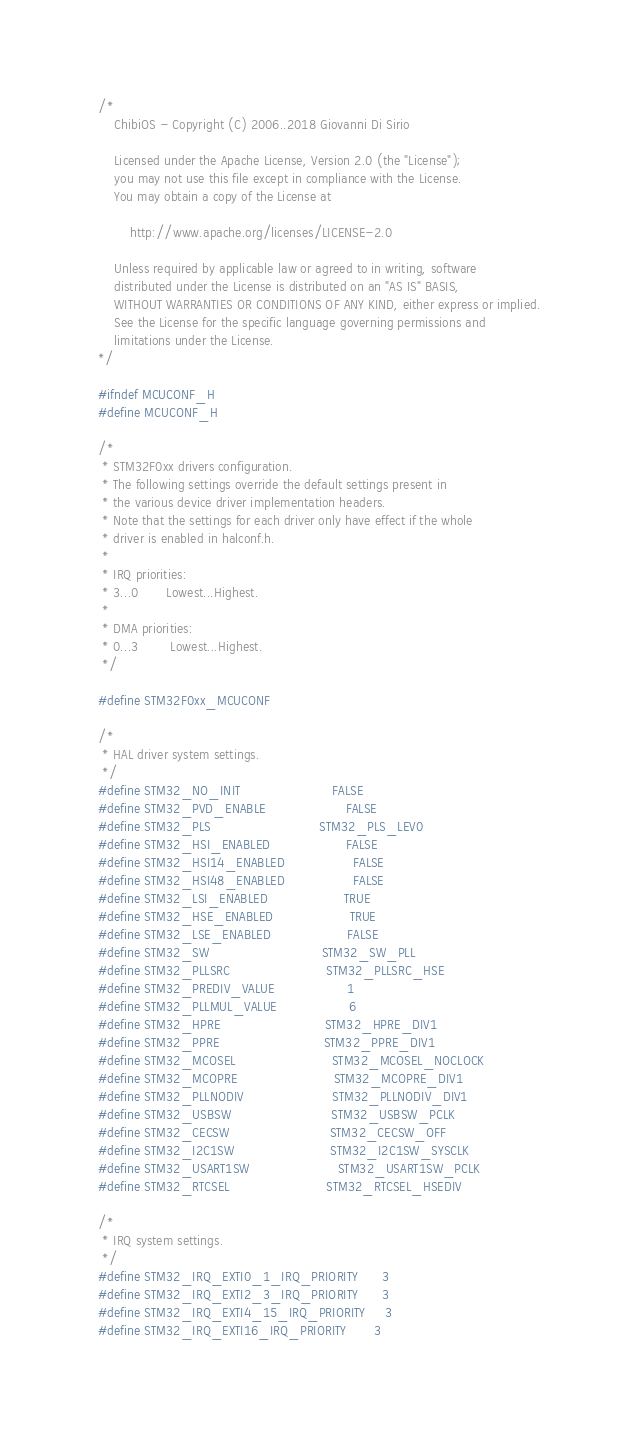Convert code to text. <code><loc_0><loc_0><loc_500><loc_500><_C_>/*
    ChibiOS - Copyright (C) 2006..2018 Giovanni Di Sirio

    Licensed under the Apache License, Version 2.0 (the "License");
    you may not use this file except in compliance with the License.
    You may obtain a copy of the License at

        http://www.apache.org/licenses/LICENSE-2.0

    Unless required by applicable law or agreed to in writing, software
    distributed under the License is distributed on an "AS IS" BASIS,
    WITHOUT WARRANTIES OR CONDITIONS OF ANY KIND, either express or implied.
    See the License for the specific language governing permissions and
    limitations under the License.
*/

#ifndef MCUCONF_H
#define MCUCONF_H

/*
 * STM32F0xx drivers configuration.
 * The following settings override the default settings present in
 * the various device driver implementation headers.
 * Note that the settings for each driver only have effect if the whole
 * driver is enabled in halconf.h.
 *
 * IRQ priorities:
 * 3...0       Lowest...Highest.
 *
 * DMA priorities:
 * 0...3        Lowest...Highest.
 */

#define STM32F0xx_MCUCONF

/*
 * HAL driver system settings.
 */
#define STM32_NO_INIT                       FALSE
#define STM32_PVD_ENABLE                    FALSE
#define STM32_PLS                           STM32_PLS_LEV0
#define STM32_HSI_ENABLED                   FALSE
#define STM32_HSI14_ENABLED                 FALSE
#define STM32_HSI48_ENABLED                 FALSE
#define STM32_LSI_ENABLED                   TRUE
#define STM32_HSE_ENABLED                   TRUE
#define STM32_LSE_ENABLED                   FALSE
#define STM32_SW                            STM32_SW_PLL
#define STM32_PLLSRC                        STM32_PLLSRC_HSE
#define STM32_PREDIV_VALUE                  1
#define STM32_PLLMUL_VALUE                  6
#define STM32_HPRE                          STM32_HPRE_DIV1
#define STM32_PPRE                          STM32_PPRE_DIV1
#define STM32_MCOSEL                        STM32_MCOSEL_NOCLOCK
#define STM32_MCOPRE                        STM32_MCOPRE_DIV1
#define STM32_PLLNODIV                      STM32_PLLNODIV_DIV1
#define STM32_USBSW                         STM32_USBSW_PCLK
#define STM32_CECSW                         STM32_CECSW_OFF
#define STM32_I2C1SW                        STM32_I2C1SW_SYSCLK
#define STM32_USART1SW                      STM32_USART1SW_PCLK
#define STM32_RTCSEL                        STM32_RTCSEL_HSEDIV

/*
 * IRQ system settings.
 */
#define STM32_IRQ_EXTI0_1_IRQ_PRIORITY      3
#define STM32_IRQ_EXTI2_3_IRQ_PRIORITY      3
#define STM32_IRQ_EXTI4_15_IRQ_PRIORITY     3
#define STM32_IRQ_EXTI16_IRQ_PRIORITY       3</code> 